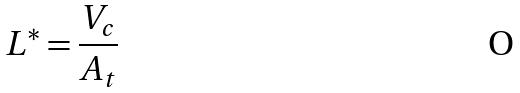Convert formula to latex. <formula><loc_0><loc_0><loc_500><loc_500>L ^ { * } = \frac { V _ { c } } { A _ { t } }</formula> 